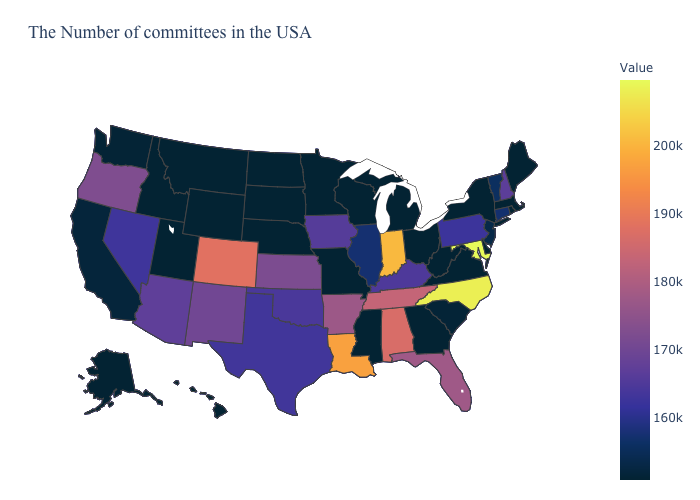Does Washington have a higher value than Connecticut?
Be succinct. No. Which states have the highest value in the USA?
Keep it brief. Maryland. Does Ohio have the lowest value in the USA?
Short answer required. Yes. Does Maryland have the highest value in the South?
Quick response, please. Yes. Does New Jersey have the lowest value in the Northeast?
Quick response, please. No. Does Ohio have the lowest value in the USA?
Be succinct. Yes. 